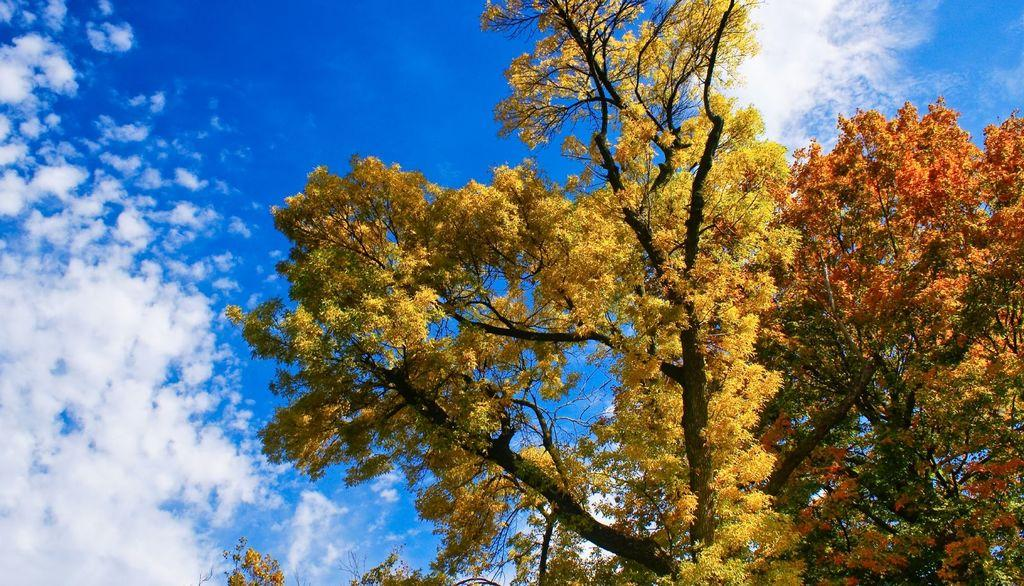What type of trees can be seen on the right side of the image? There are trees with yellow leaves and trees with red leaves on the right side of the image. What is visible in the background of the image? The sky is visible in the background of the image. What can be observed in the sky? Clouds are present in the sky. What type of unit is being measured during the holiday in the image? There is no unit or holiday mentioned or depicted in the image. 